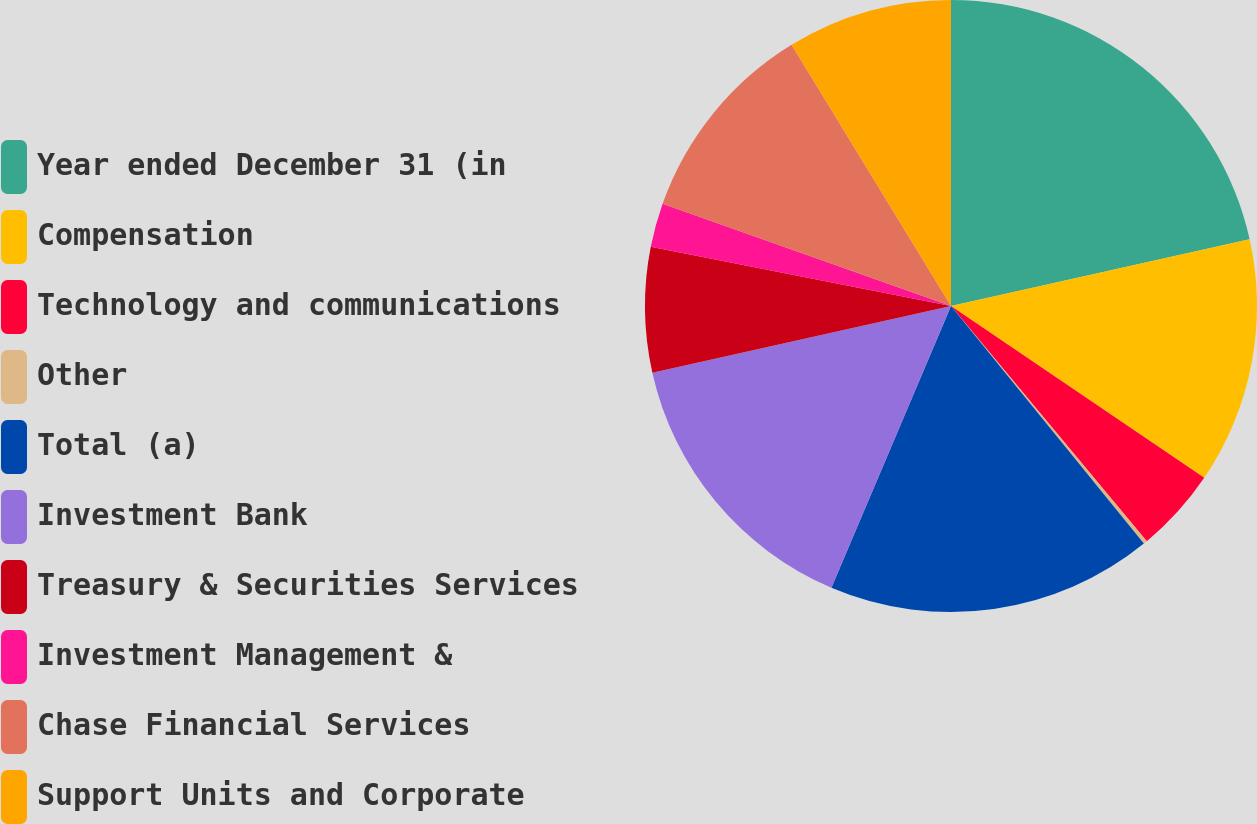Convert chart to OTSL. <chart><loc_0><loc_0><loc_500><loc_500><pie_chart><fcel>Year ended December 31 (in<fcel>Compensation<fcel>Technology and communications<fcel>Other<fcel>Total (a)<fcel>Investment Bank<fcel>Treasury & Securities Services<fcel>Investment Management &<fcel>Chase Financial Services<fcel>Support Units and Corporate<nl><fcel>21.5%<fcel>12.98%<fcel>4.46%<fcel>0.2%<fcel>17.24%<fcel>15.11%<fcel>6.59%<fcel>2.33%<fcel>10.85%<fcel>8.72%<nl></chart> 